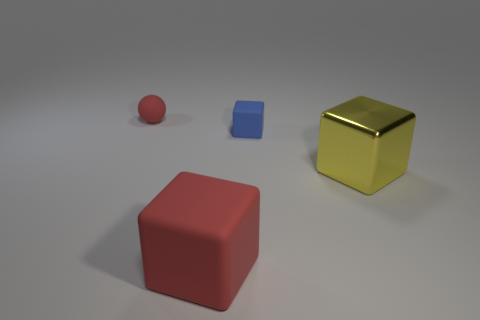Subtract all metallic blocks. How many blocks are left? 2 Add 4 large brown balls. How many objects exist? 8 Subtract all brown cubes. Subtract all blue cylinders. How many cubes are left? 3 Subtract all balls. How many objects are left? 3 Add 4 large things. How many large things exist? 6 Subtract 0 blue balls. How many objects are left? 4 Subtract all red rubber cylinders. Subtract all small red objects. How many objects are left? 3 Add 1 blue rubber things. How many blue rubber things are left? 2 